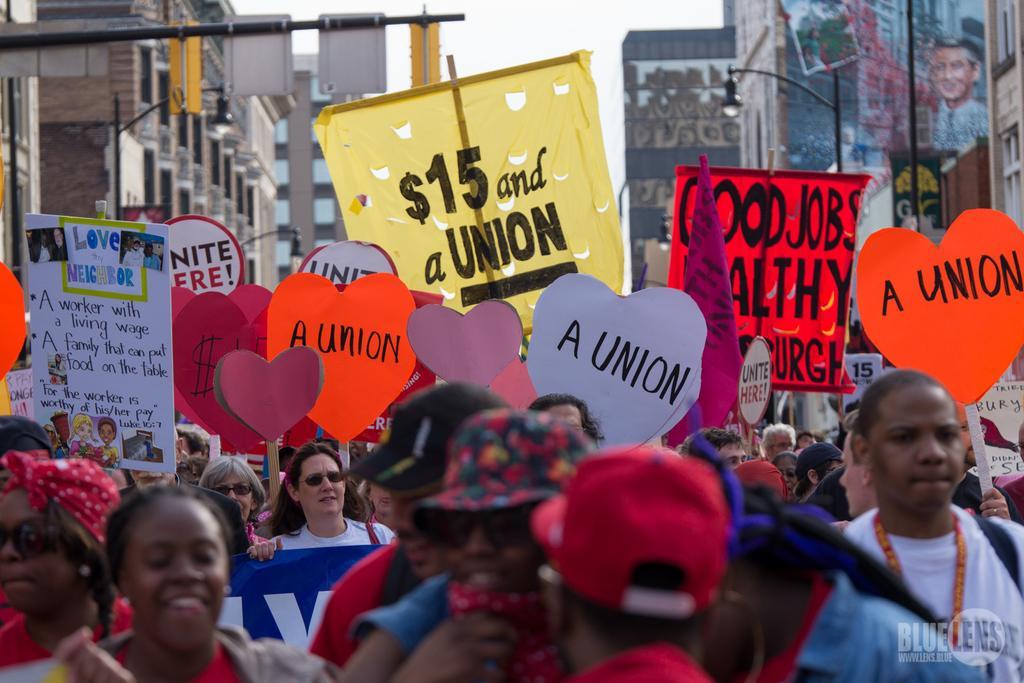Describe this image in one or two sentences. In this picture there are group of people holding and placards and there is text on the placards. At the back there is a building and there are poles and there is a painting of the person on the wall. At the top there is sky. 